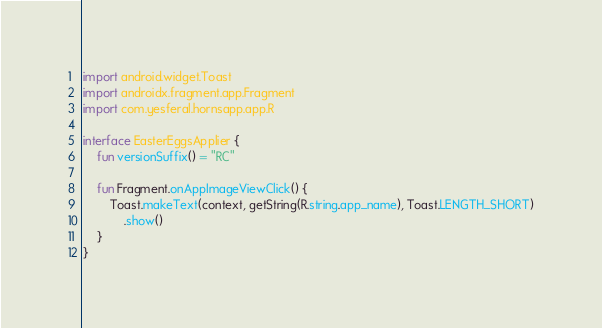Convert code to text. <code><loc_0><loc_0><loc_500><loc_500><_Kotlin_>
import android.widget.Toast
import androidx.fragment.app.Fragment
import com.yesferal.hornsapp.app.R

interface EasterEggsApplier {
    fun versionSuffix() = "RC"

    fun Fragment.onAppImageViewClick() {
        Toast.makeText(context, getString(R.string.app_name), Toast.LENGTH_SHORT)
            .show()
    }
}</code> 